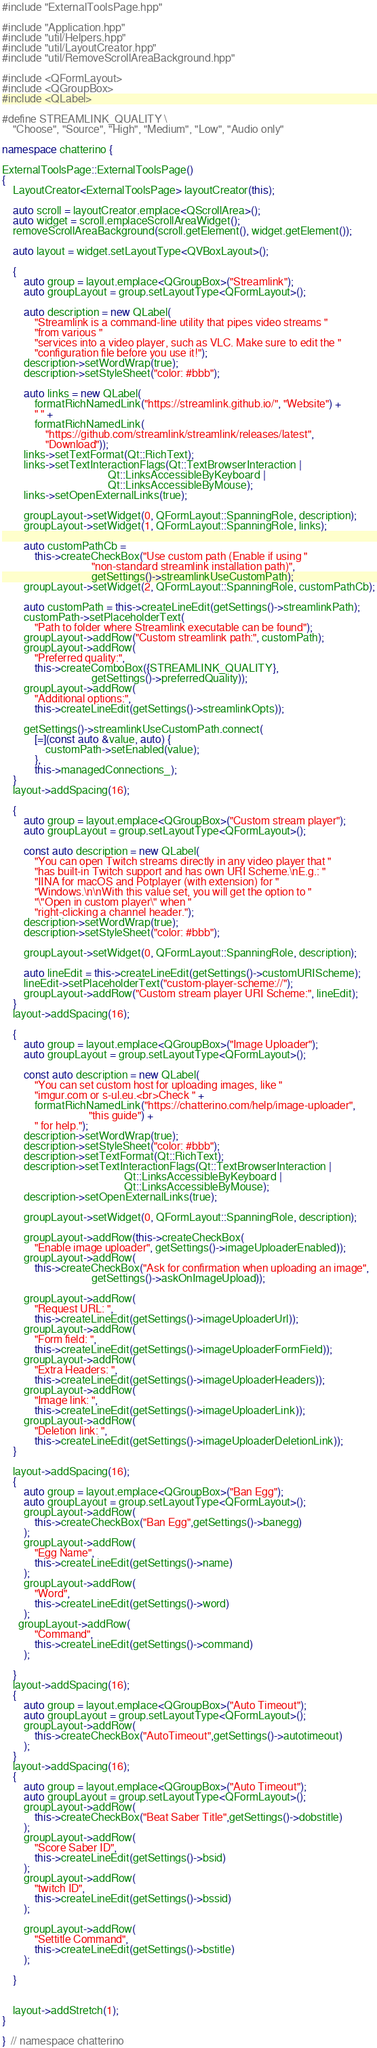<code> <loc_0><loc_0><loc_500><loc_500><_C++_>#include "ExternalToolsPage.hpp"

#include "Application.hpp"
#include "util/Helpers.hpp"
#include "util/LayoutCreator.hpp"
#include "util/RemoveScrollAreaBackground.hpp"

#include <QFormLayout>
#include <QGroupBox>
#include <QLabel>

#define STREAMLINK_QUALITY \
    "Choose", "Source", "High", "Medium", "Low", "Audio only"

namespace chatterino {

ExternalToolsPage::ExternalToolsPage()
{
    LayoutCreator<ExternalToolsPage> layoutCreator(this);

    auto scroll = layoutCreator.emplace<QScrollArea>();
    auto widget = scroll.emplaceScrollAreaWidget();
    removeScrollAreaBackground(scroll.getElement(), widget.getElement());

    auto layout = widget.setLayoutType<QVBoxLayout>();

    {
        auto group = layout.emplace<QGroupBox>("Streamlink");
        auto groupLayout = group.setLayoutType<QFormLayout>();

        auto description = new QLabel(
            "Streamlink is a command-line utility that pipes video streams "
            "from various "
            "services into a video player, such as VLC. Make sure to edit the "
            "configuration file before you use it!");
        description->setWordWrap(true);
        description->setStyleSheet("color: #bbb");

        auto links = new QLabel(
            formatRichNamedLink("https://streamlink.github.io/", "Website") +
            " " +
            formatRichNamedLink(
                "https://github.com/streamlink/streamlink/releases/latest",
                "Download"));
        links->setTextFormat(Qt::RichText);
        links->setTextInteractionFlags(Qt::TextBrowserInteraction |
                                       Qt::LinksAccessibleByKeyboard |
                                       Qt::LinksAccessibleByMouse);
        links->setOpenExternalLinks(true);

        groupLayout->setWidget(0, QFormLayout::SpanningRole, description);
        groupLayout->setWidget(1, QFormLayout::SpanningRole, links);

        auto customPathCb =
            this->createCheckBox("Use custom path (Enable if using "
                                 "non-standard streamlink installation path)",
                                 getSettings()->streamlinkUseCustomPath);
        groupLayout->setWidget(2, QFormLayout::SpanningRole, customPathCb);

        auto customPath = this->createLineEdit(getSettings()->streamlinkPath);
        customPath->setPlaceholderText(
            "Path to folder where Streamlink executable can be found");
        groupLayout->addRow("Custom streamlink path:", customPath);
        groupLayout->addRow(
            "Preferred quality:",
            this->createComboBox({STREAMLINK_QUALITY},
                                 getSettings()->preferredQuality));
        groupLayout->addRow(
            "Additional options:",
            this->createLineEdit(getSettings()->streamlinkOpts));

        getSettings()->streamlinkUseCustomPath.connect(
            [=](const auto &value, auto) {
                customPath->setEnabled(value);
            },
            this->managedConnections_);
    }
    layout->addSpacing(16);

    {
        auto group = layout.emplace<QGroupBox>("Custom stream player");
        auto groupLayout = group.setLayoutType<QFormLayout>();

        const auto description = new QLabel(
            "You can open Twitch streams directly in any video player that "
            "has built-in Twitch support and has own URI Scheme.\nE.g.: "
            "IINA for macOS and Potplayer (with extension) for "
            "Windows.\n\nWith this value set, you will get the option to "
            "\"Open in custom player\" when "
            "right-clicking a channel header.");
        description->setWordWrap(true);
        description->setStyleSheet("color: #bbb");

        groupLayout->setWidget(0, QFormLayout::SpanningRole, description);

        auto lineEdit = this->createLineEdit(getSettings()->customURIScheme);
        lineEdit->setPlaceholderText("custom-player-scheme://");
        groupLayout->addRow("Custom stream player URI Scheme:", lineEdit);
    }
    layout->addSpacing(16);

    {
        auto group = layout.emplace<QGroupBox>("Image Uploader");
        auto groupLayout = group.setLayoutType<QFormLayout>();

        const auto description = new QLabel(
            "You can set custom host for uploading images, like "
            "imgur.com or s-ul.eu.<br>Check " +
            formatRichNamedLink("https://chatterino.com/help/image-uploader",
                                "this guide") +
            " for help.");
        description->setWordWrap(true);
        description->setStyleSheet("color: #bbb");
        description->setTextFormat(Qt::RichText);
        description->setTextInteractionFlags(Qt::TextBrowserInteraction |
                                             Qt::LinksAccessibleByKeyboard |
                                             Qt::LinksAccessibleByMouse);
        description->setOpenExternalLinks(true);

        groupLayout->setWidget(0, QFormLayout::SpanningRole, description);

        groupLayout->addRow(this->createCheckBox(
            "Enable image uploader", getSettings()->imageUploaderEnabled));
        groupLayout->addRow(
            this->createCheckBox("Ask for confirmation when uploading an image",
                                 getSettings()->askOnImageUpload));

        groupLayout->addRow(
            "Request URL: ",
            this->createLineEdit(getSettings()->imageUploaderUrl));
        groupLayout->addRow(
            "Form field: ",
            this->createLineEdit(getSettings()->imageUploaderFormField));
        groupLayout->addRow(
            "Extra Headers: ",
            this->createLineEdit(getSettings()->imageUploaderHeaders));
        groupLayout->addRow(
            "Image link: ",
            this->createLineEdit(getSettings()->imageUploaderLink));
        groupLayout->addRow(
            "Deletion link: ",
            this->createLineEdit(getSettings()->imageUploaderDeletionLink));
    }

    layout->addSpacing(16);
	{
        auto group = layout.emplace<QGroupBox>("Ban Egg");
        auto groupLayout = group.setLayoutType<QFormLayout>();
		groupLayout->addRow(
			this->createCheckBox("Ban Egg",getSettings()->banegg)
		);
        groupLayout->addRow(
			"Egg Name",
			this->createLineEdit(getSettings()->name)
		);
		groupLayout->addRow(
			"Word",
			this->createLineEdit(getSettings()->word)
		);
	  groupLayout->addRow(
    		"Command",
	  		this->createLineEdit(getSettings()->command)
		);

	}
	layout->addSpacing(16);
	{
        auto group = layout.emplace<QGroupBox>("Auto Timeout");
        auto groupLayout = group.setLayoutType<QFormLayout>();
		groupLayout->addRow(
			this->createCheckBox("AutoTimeout",getSettings()->autotimeout)
		);
	}
	layout->addSpacing(16);
	{
        auto group = layout.emplace<QGroupBox>("Auto Timeout");
        auto groupLayout = group.setLayoutType<QFormLayout>();
		groupLayout->addRow(
			this->createCheckBox("Beat Saber Title",getSettings()->dobstitle)
		);
		groupLayout->addRow(
			"Score Saber ID",	
	  		this->createLineEdit(getSettings()->bsid)
		);
		groupLayout->addRow(
			"twitch ID",	
	  		this->createLineEdit(getSettings()->bssid)
		);

		groupLayout->addRow(
			"Settitle Command",	
	  		this->createLineEdit(getSettings()->bstitle)
		);

	}


    layout->addStretch(1);
}

}  // namespace chatterino
</code> 